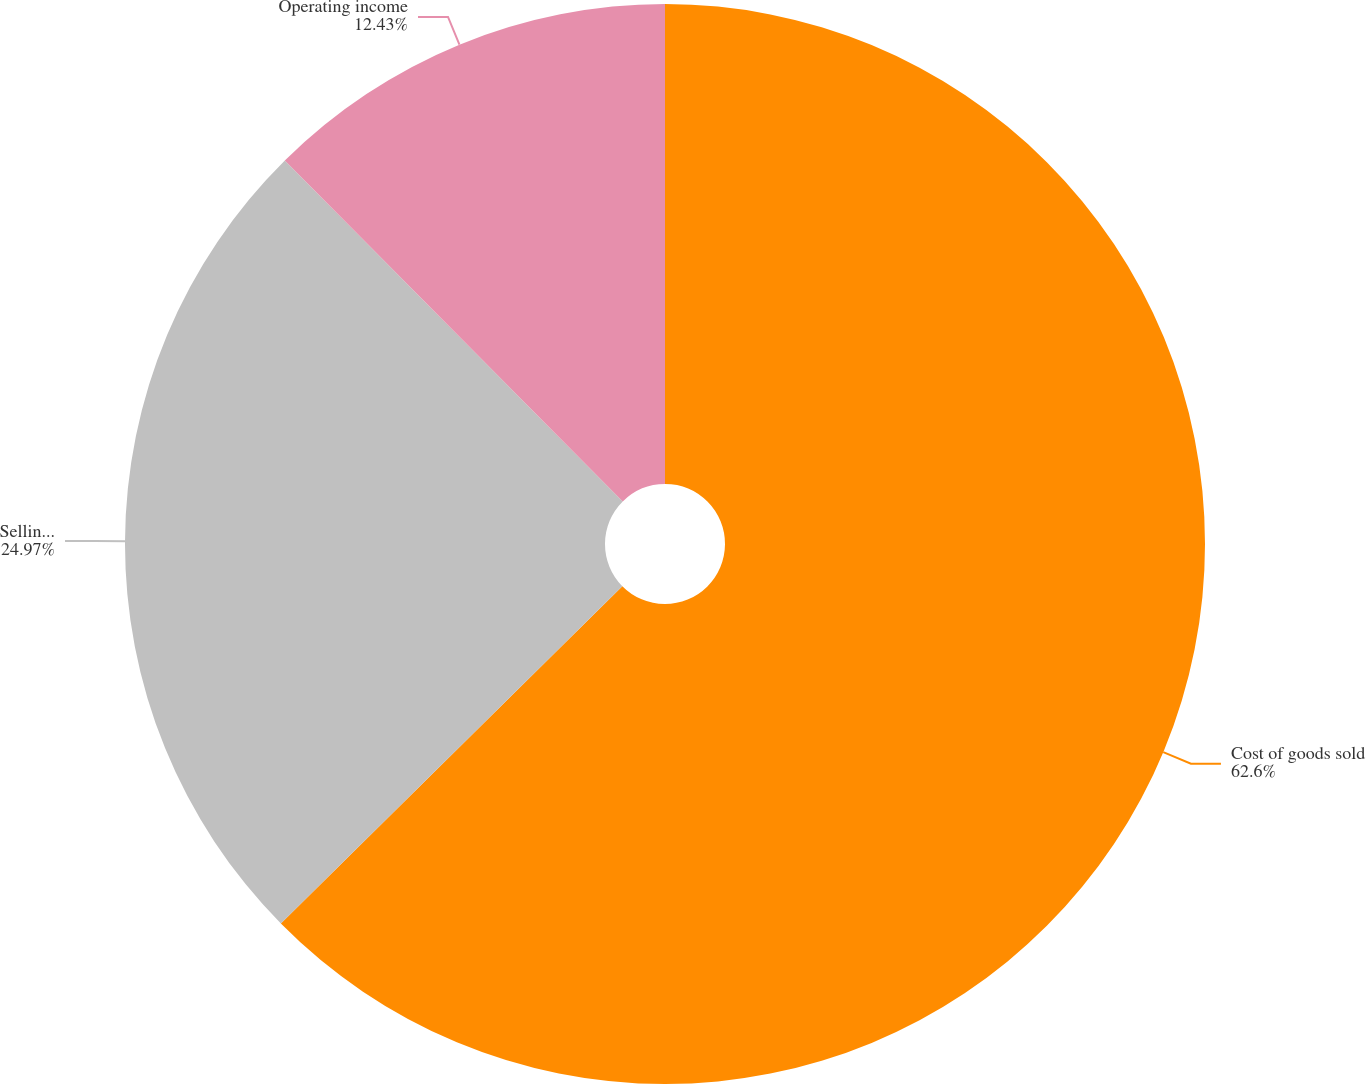Convert chart to OTSL. <chart><loc_0><loc_0><loc_500><loc_500><pie_chart><fcel>Cost of goods sold<fcel>Selling and administrative<fcel>Operating income<nl><fcel>62.59%<fcel>24.97%<fcel>12.43%<nl></chart> 